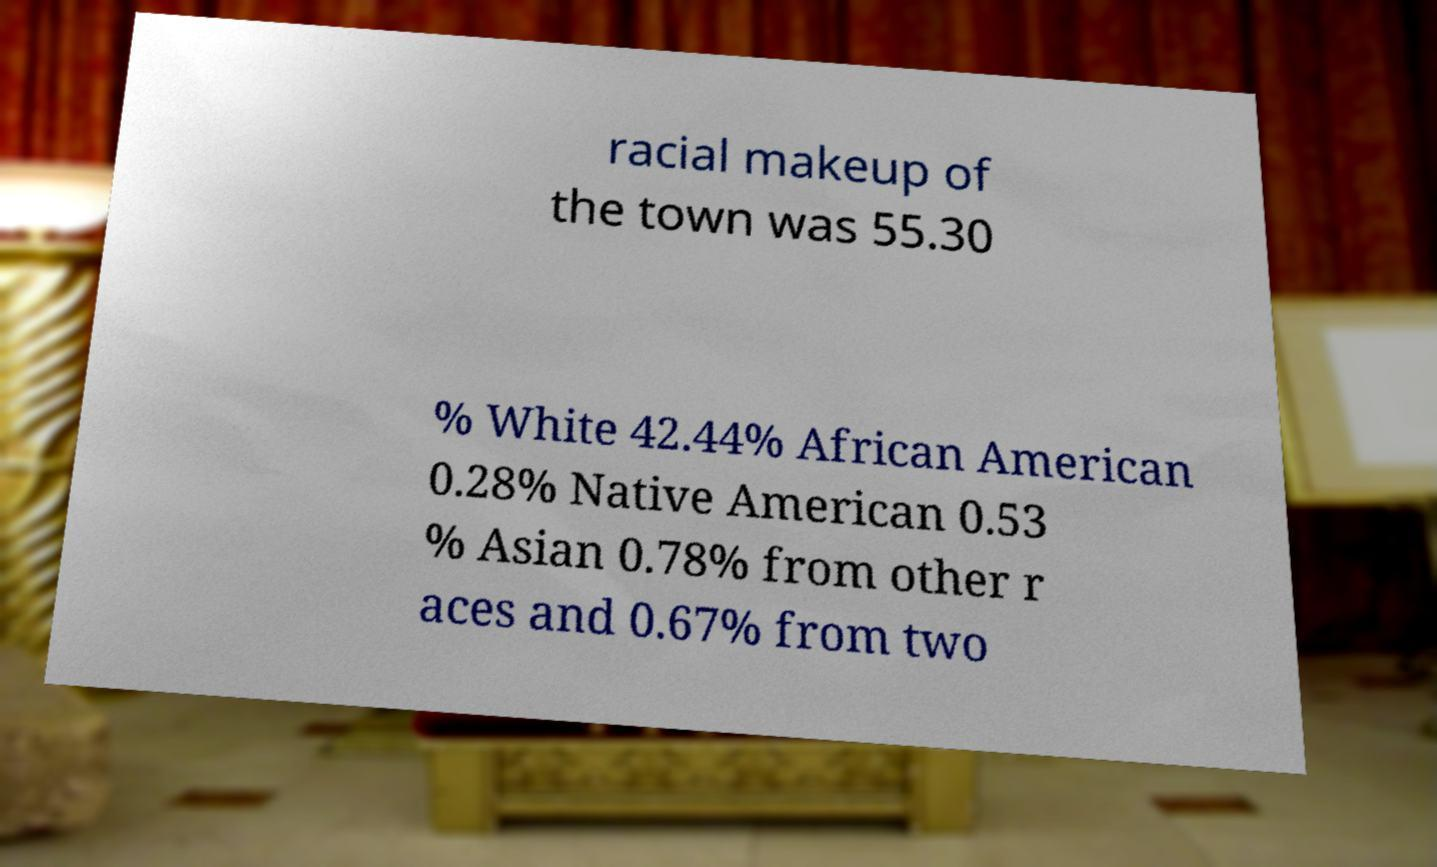Please identify and transcribe the text found in this image. racial makeup of the town was 55.30 % White 42.44% African American 0.28% Native American 0.53 % Asian 0.78% from other r aces and 0.67% from two 